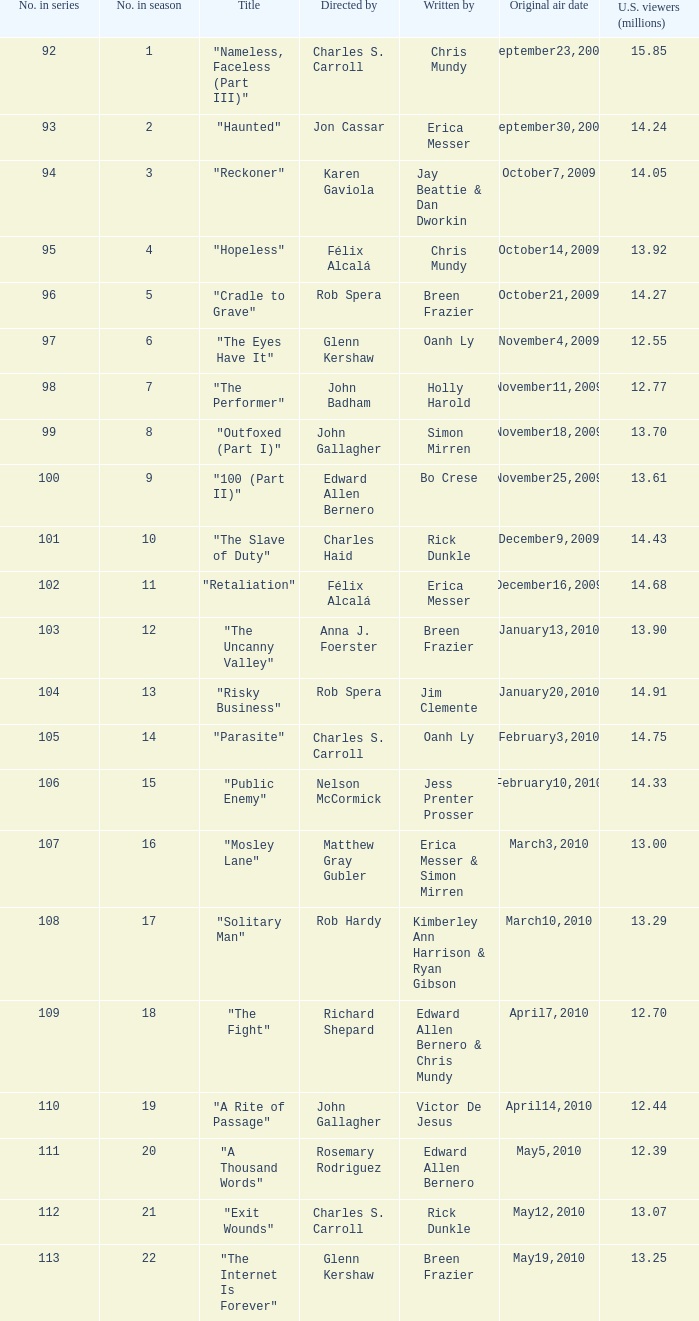What number(s) in the series was written by bo crese? 100.0. 